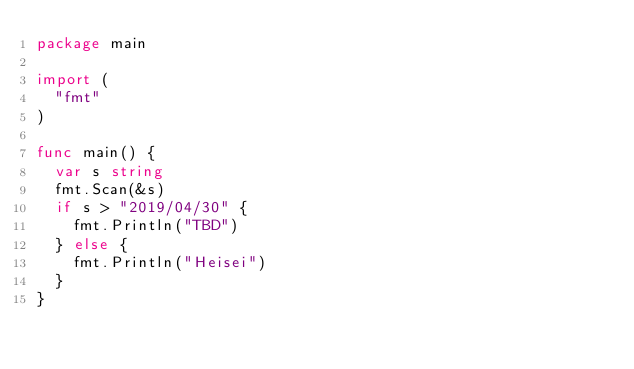<code> <loc_0><loc_0><loc_500><loc_500><_Go_>package main

import (
  "fmt"
)

func main() {
  var s string
  fmt.Scan(&s)
  if s > "2019/04/30" {
    fmt.Println("TBD")
  } else {
    fmt.Println("Heisei")
  }
}
</code> 